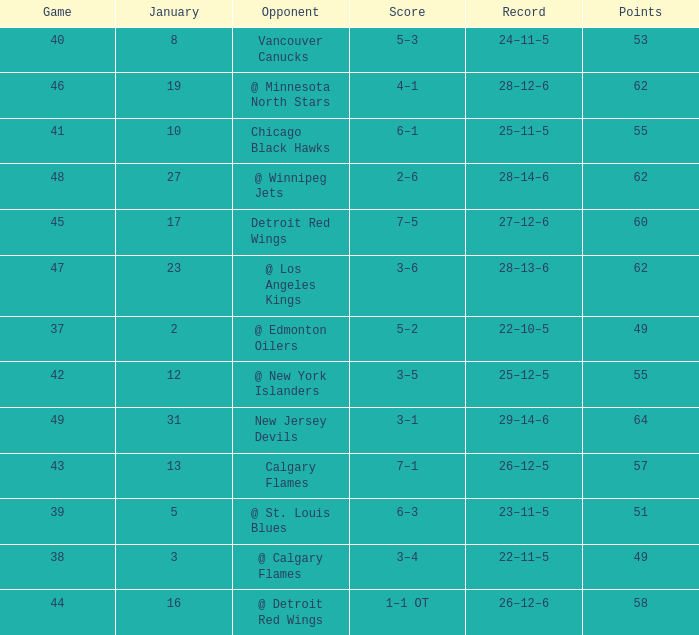Which Points have a Score of 4–1? 62.0. 